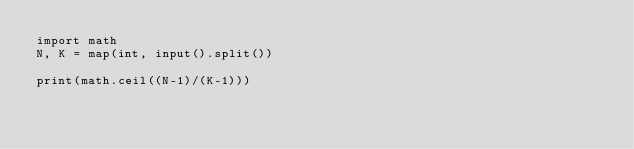Convert code to text. <code><loc_0><loc_0><loc_500><loc_500><_Python_>import math
N, K = map(int, input().split())

print(math.ceil((N-1)/(K-1)))</code> 